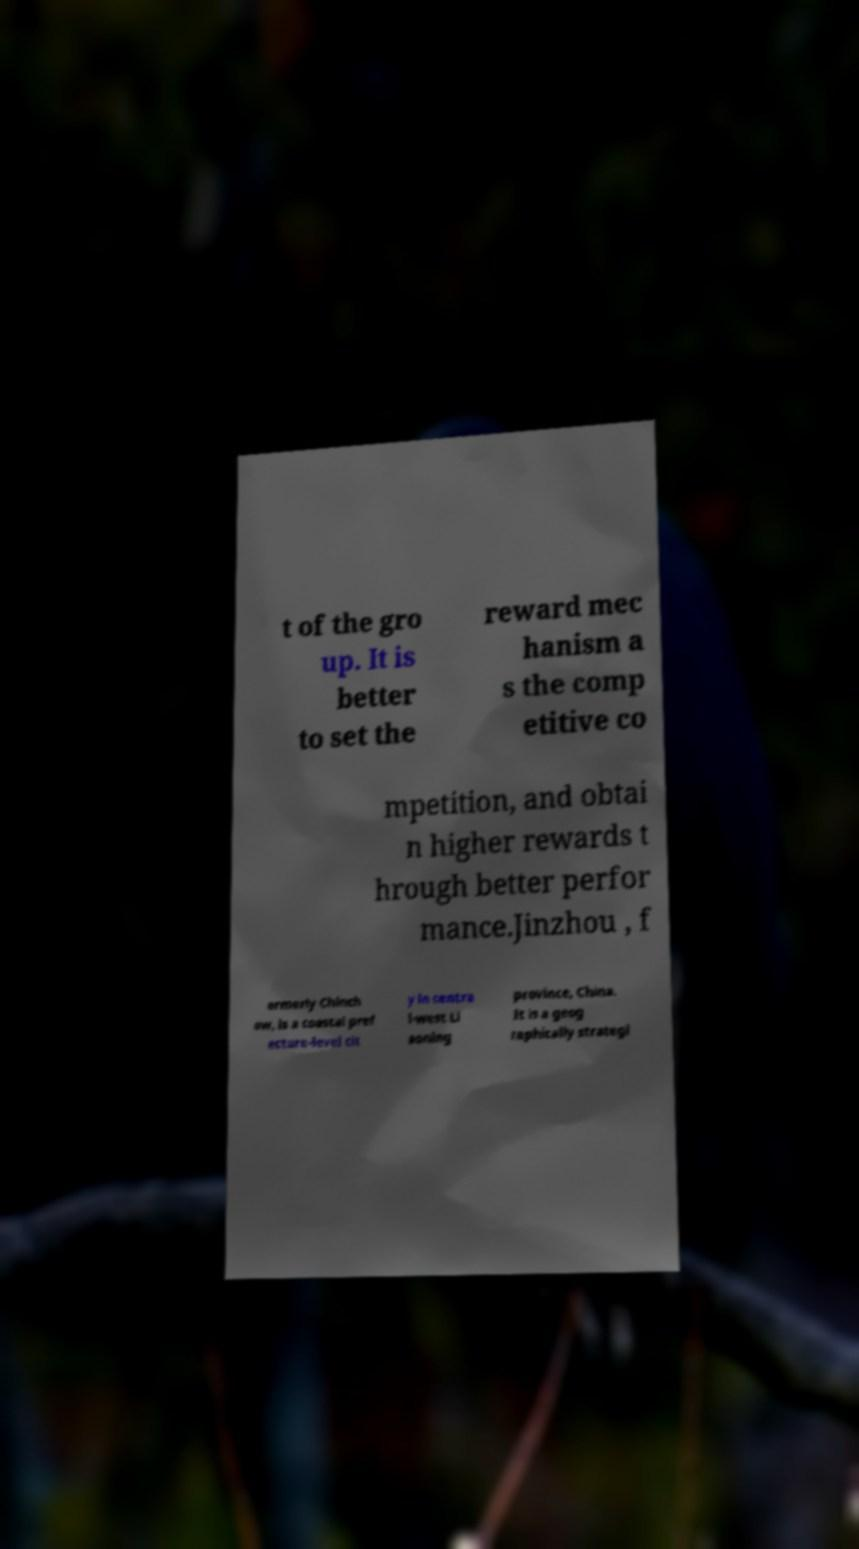There's text embedded in this image that I need extracted. Can you transcribe it verbatim? t of the gro up. It is better to set the reward mec hanism a s the comp etitive co mpetition, and obtai n higher rewards t hrough better perfor mance.Jinzhou , f ormerly Chinch ow, is a coastal pref ecture-level cit y in centra l-west Li aoning province, China. It is a geog raphically strategi 